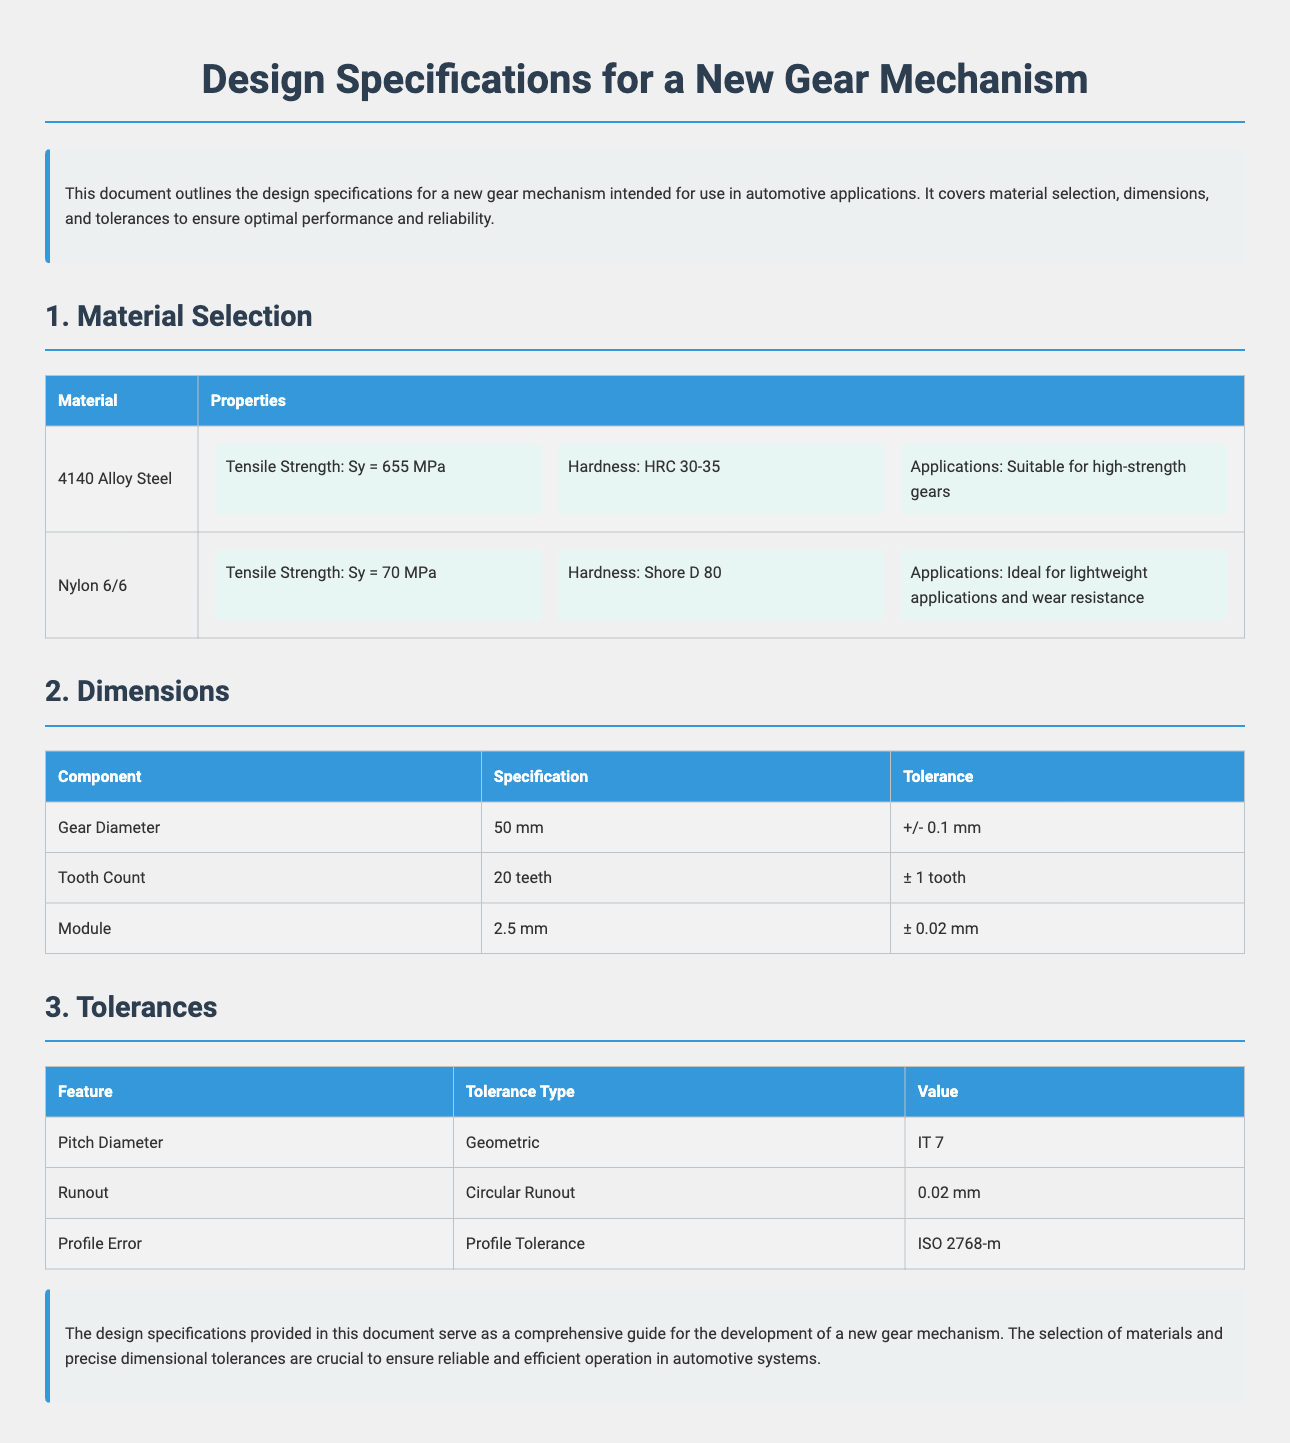What is the tensile strength of 4140 Alloy Steel? The tensile strength of 4140 Alloy Steel is specified in the material selection section as 655 MPa.
Answer: 655 MPa What is the gear diameter? The gear diameter is located in the dimensions section of the document, listed as 50 mm.
Answer: 50 mm What is the tolerance for the module? The module tolerance is detailed in the dimensions section, which specifies ± 0.02 mm.
Answer: ± 0.02 mm How many teeth does the gear have? The tooth count for the gear is mentioned in the dimensions section as 20 teeth.
Answer: 20 teeth What is the hardness rating for Nylon 6/6? The hardness for Nylon 6/6 is noted in the material selection table as Shore D 80.
Answer: Shore D 80 Which material is suitable for high-strength gears? The material selection section indicates that 4140 Alloy Steel is suitable for high-strength gears.
Answer: 4140 Alloy Steel What type of tolerance is specified for the pitch diameter? The tolerance for the pitch diameter is identified as geometric in the tolerances section of the document.
Answer: Geometric What is the value of circular runout? The circular runout value is provided in the tolerances table as 0.02 mm.
Answer: 0.02 mm What is the application of Nylon 6/6? The application for Nylon 6/6 is described in the material selection section as ideal for lightweight applications and wear resistance.
Answer: Ideal for lightweight applications and wear resistance 